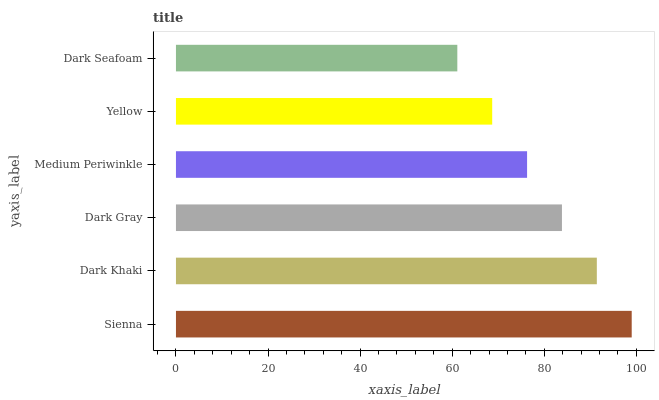Is Dark Seafoam the minimum?
Answer yes or no. Yes. Is Sienna the maximum?
Answer yes or no. Yes. Is Dark Khaki the minimum?
Answer yes or no. No. Is Dark Khaki the maximum?
Answer yes or no. No. Is Sienna greater than Dark Khaki?
Answer yes or no. Yes. Is Dark Khaki less than Sienna?
Answer yes or no. Yes. Is Dark Khaki greater than Sienna?
Answer yes or no. No. Is Sienna less than Dark Khaki?
Answer yes or no. No. Is Dark Gray the high median?
Answer yes or no. Yes. Is Medium Periwinkle the low median?
Answer yes or no. Yes. Is Medium Periwinkle the high median?
Answer yes or no. No. Is Dark Gray the low median?
Answer yes or no. No. 